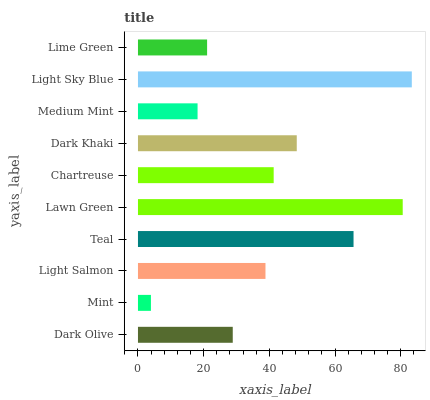Is Mint the minimum?
Answer yes or no. Yes. Is Light Sky Blue the maximum?
Answer yes or no. Yes. Is Light Salmon the minimum?
Answer yes or no. No. Is Light Salmon the maximum?
Answer yes or no. No. Is Light Salmon greater than Mint?
Answer yes or no. Yes. Is Mint less than Light Salmon?
Answer yes or no. Yes. Is Mint greater than Light Salmon?
Answer yes or no. No. Is Light Salmon less than Mint?
Answer yes or no. No. Is Chartreuse the high median?
Answer yes or no. Yes. Is Light Salmon the low median?
Answer yes or no. Yes. Is Teal the high median?
Answer yes or no. No. Is Mint the low median?
Answer yes or no. No. 